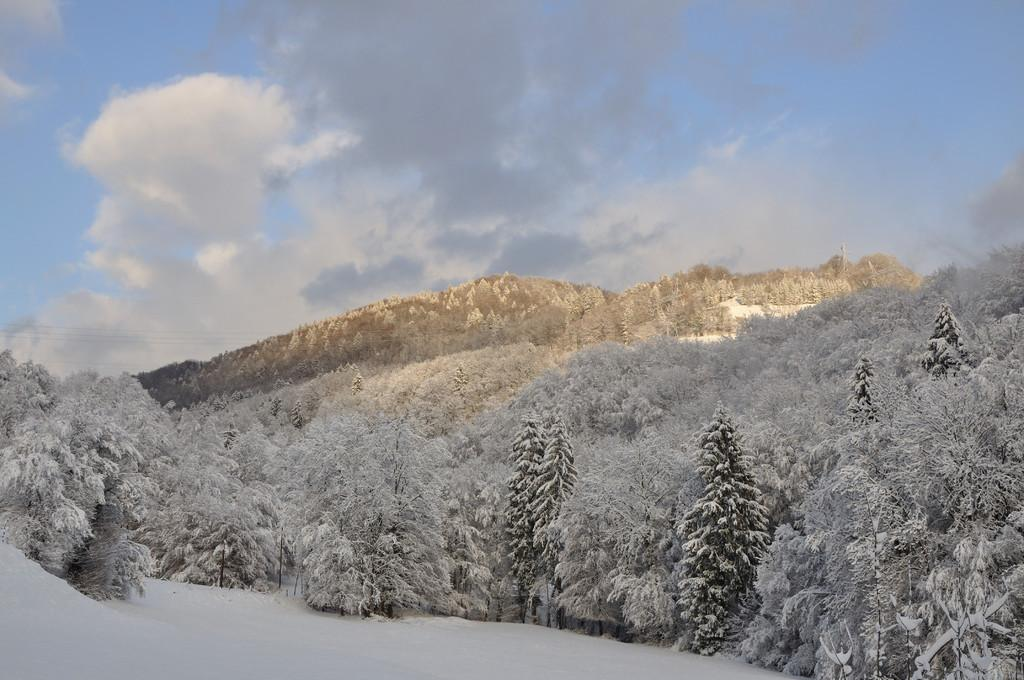What type of vegetation is present in the image? There is a group of trees in the image. What is covering the trees in the image? The trees are covered with snow. What can be seen in the distance behind the trees? There are mountains visible in the background of the image. What is the condition of the sky in the image? The sky is cloudy in the background of the image. What time of day is the discussion taking place in the image? There is no discussion taking place in the image; it is a scene of trees, snow, mountains, and a cloudy sky. 